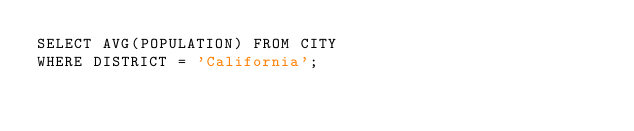<code> <loc_0><loc_0><loc_500><loc_500><_SQL_>SELECT AVG(POPULATION) FROM CITY
WHERE DISTRICT = 'California';
</code> 